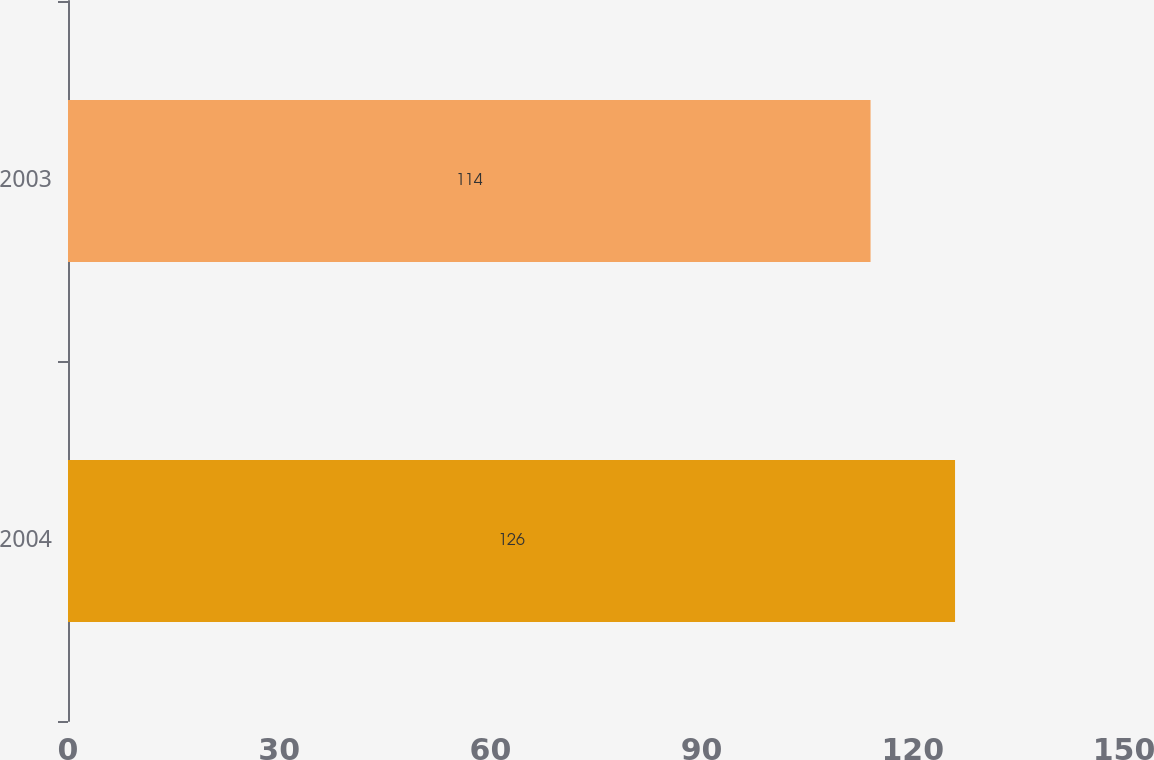<chart> <loc_0><loc_0><loc_500><loc_500><bar_chart><fcel>2004<fcel>2003<nl><fcel>126<fcel>114<nl></chart> 